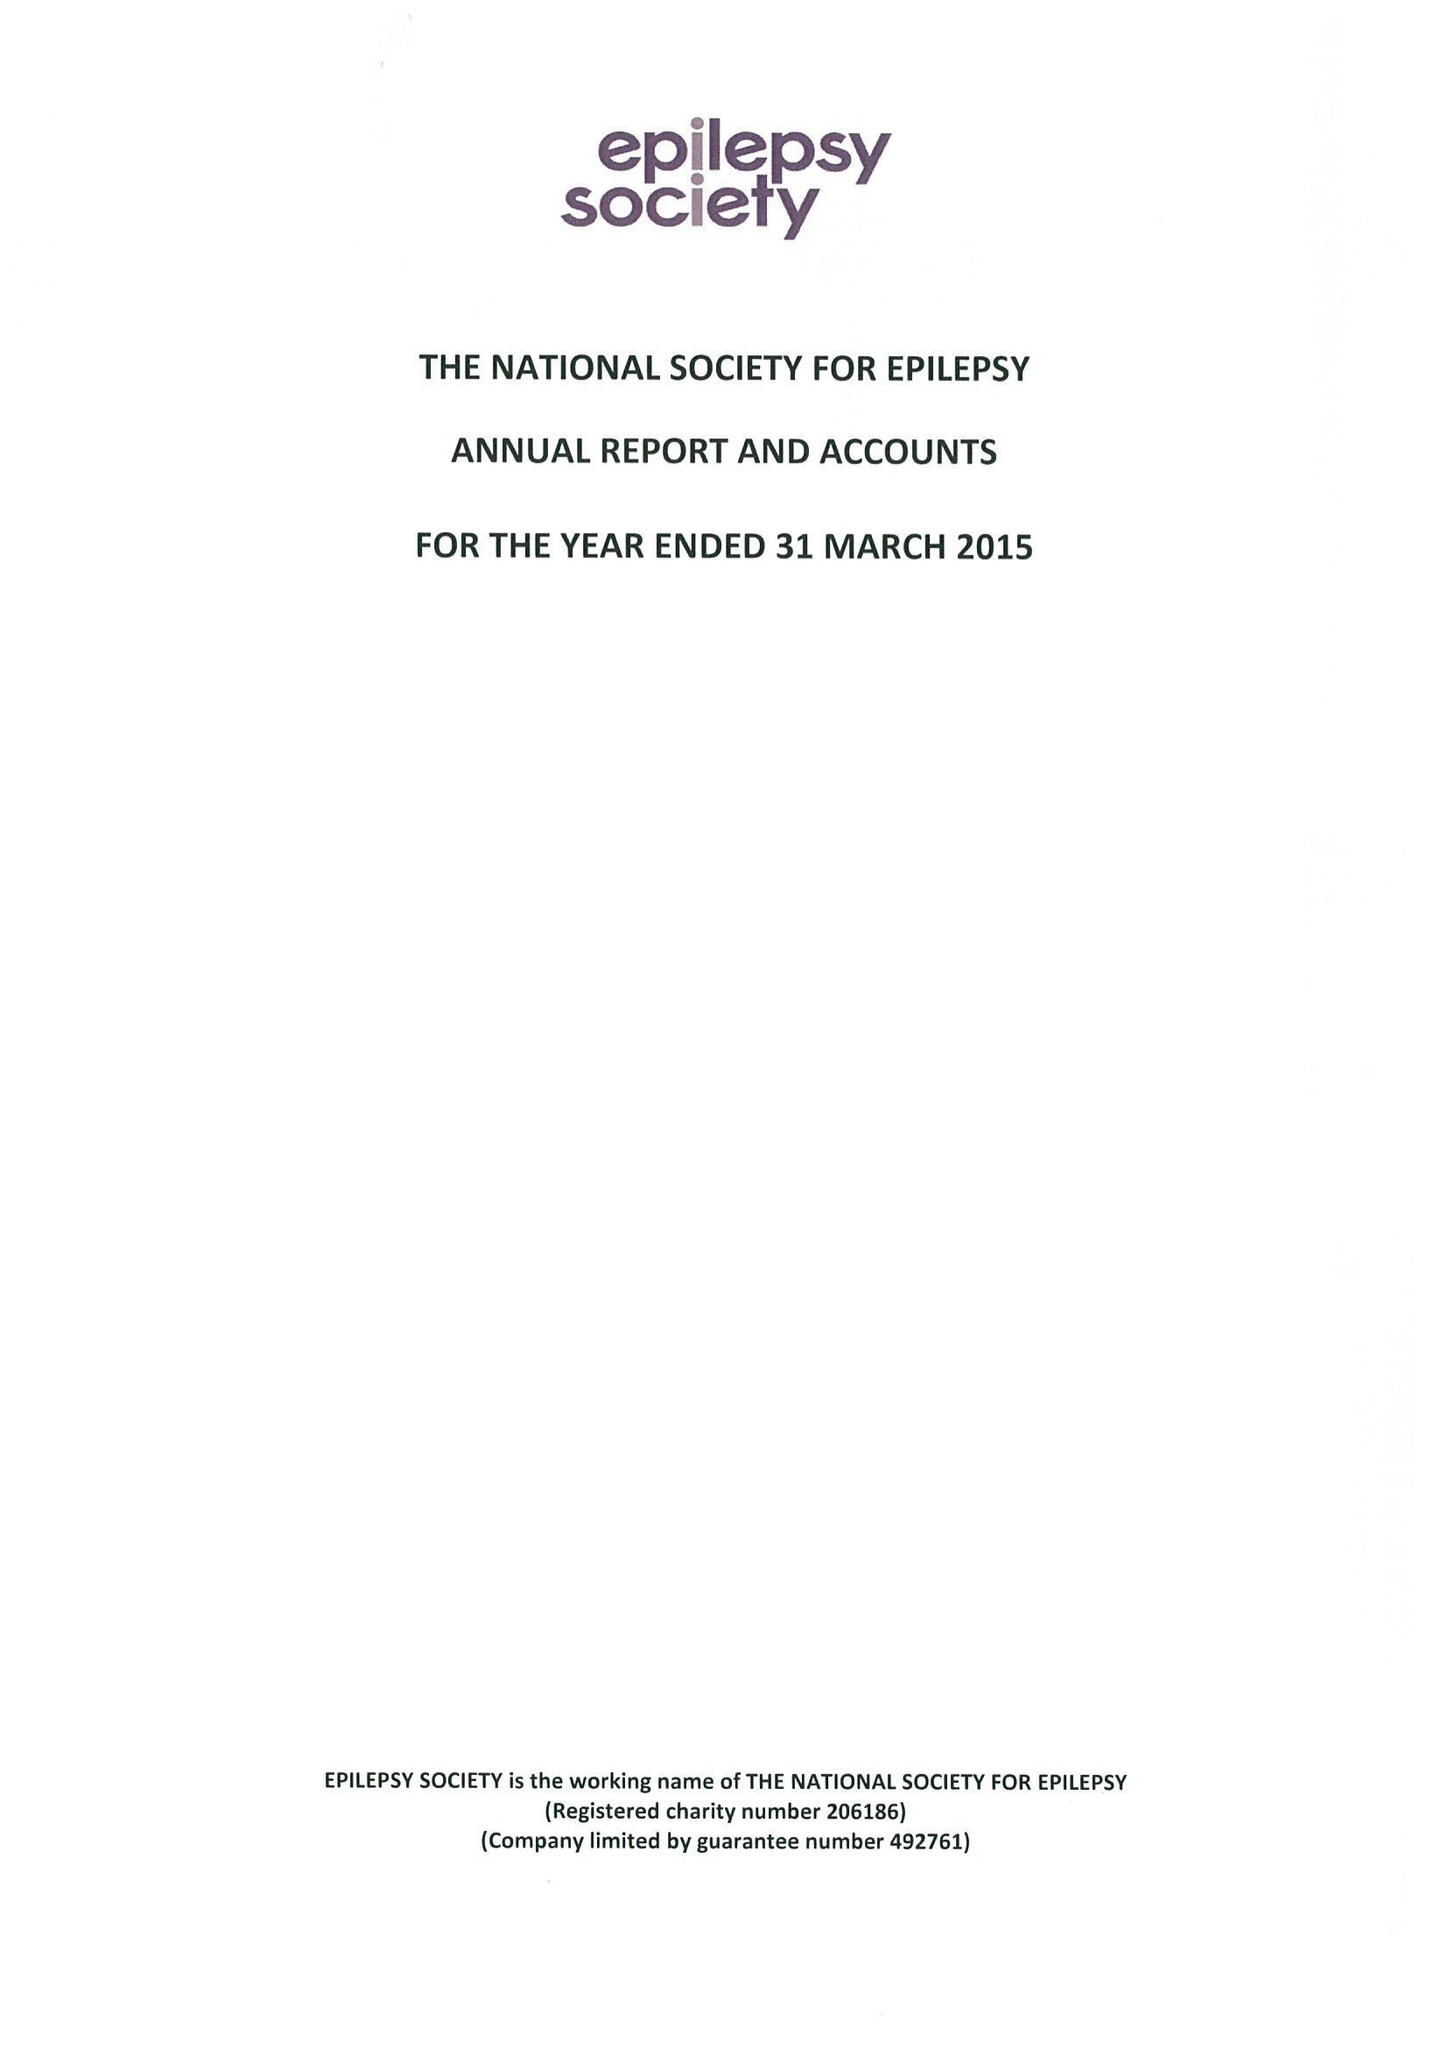What is the value for the address__post_town?
Answer the question using a single word or phrase. GERRARDS CROSS 